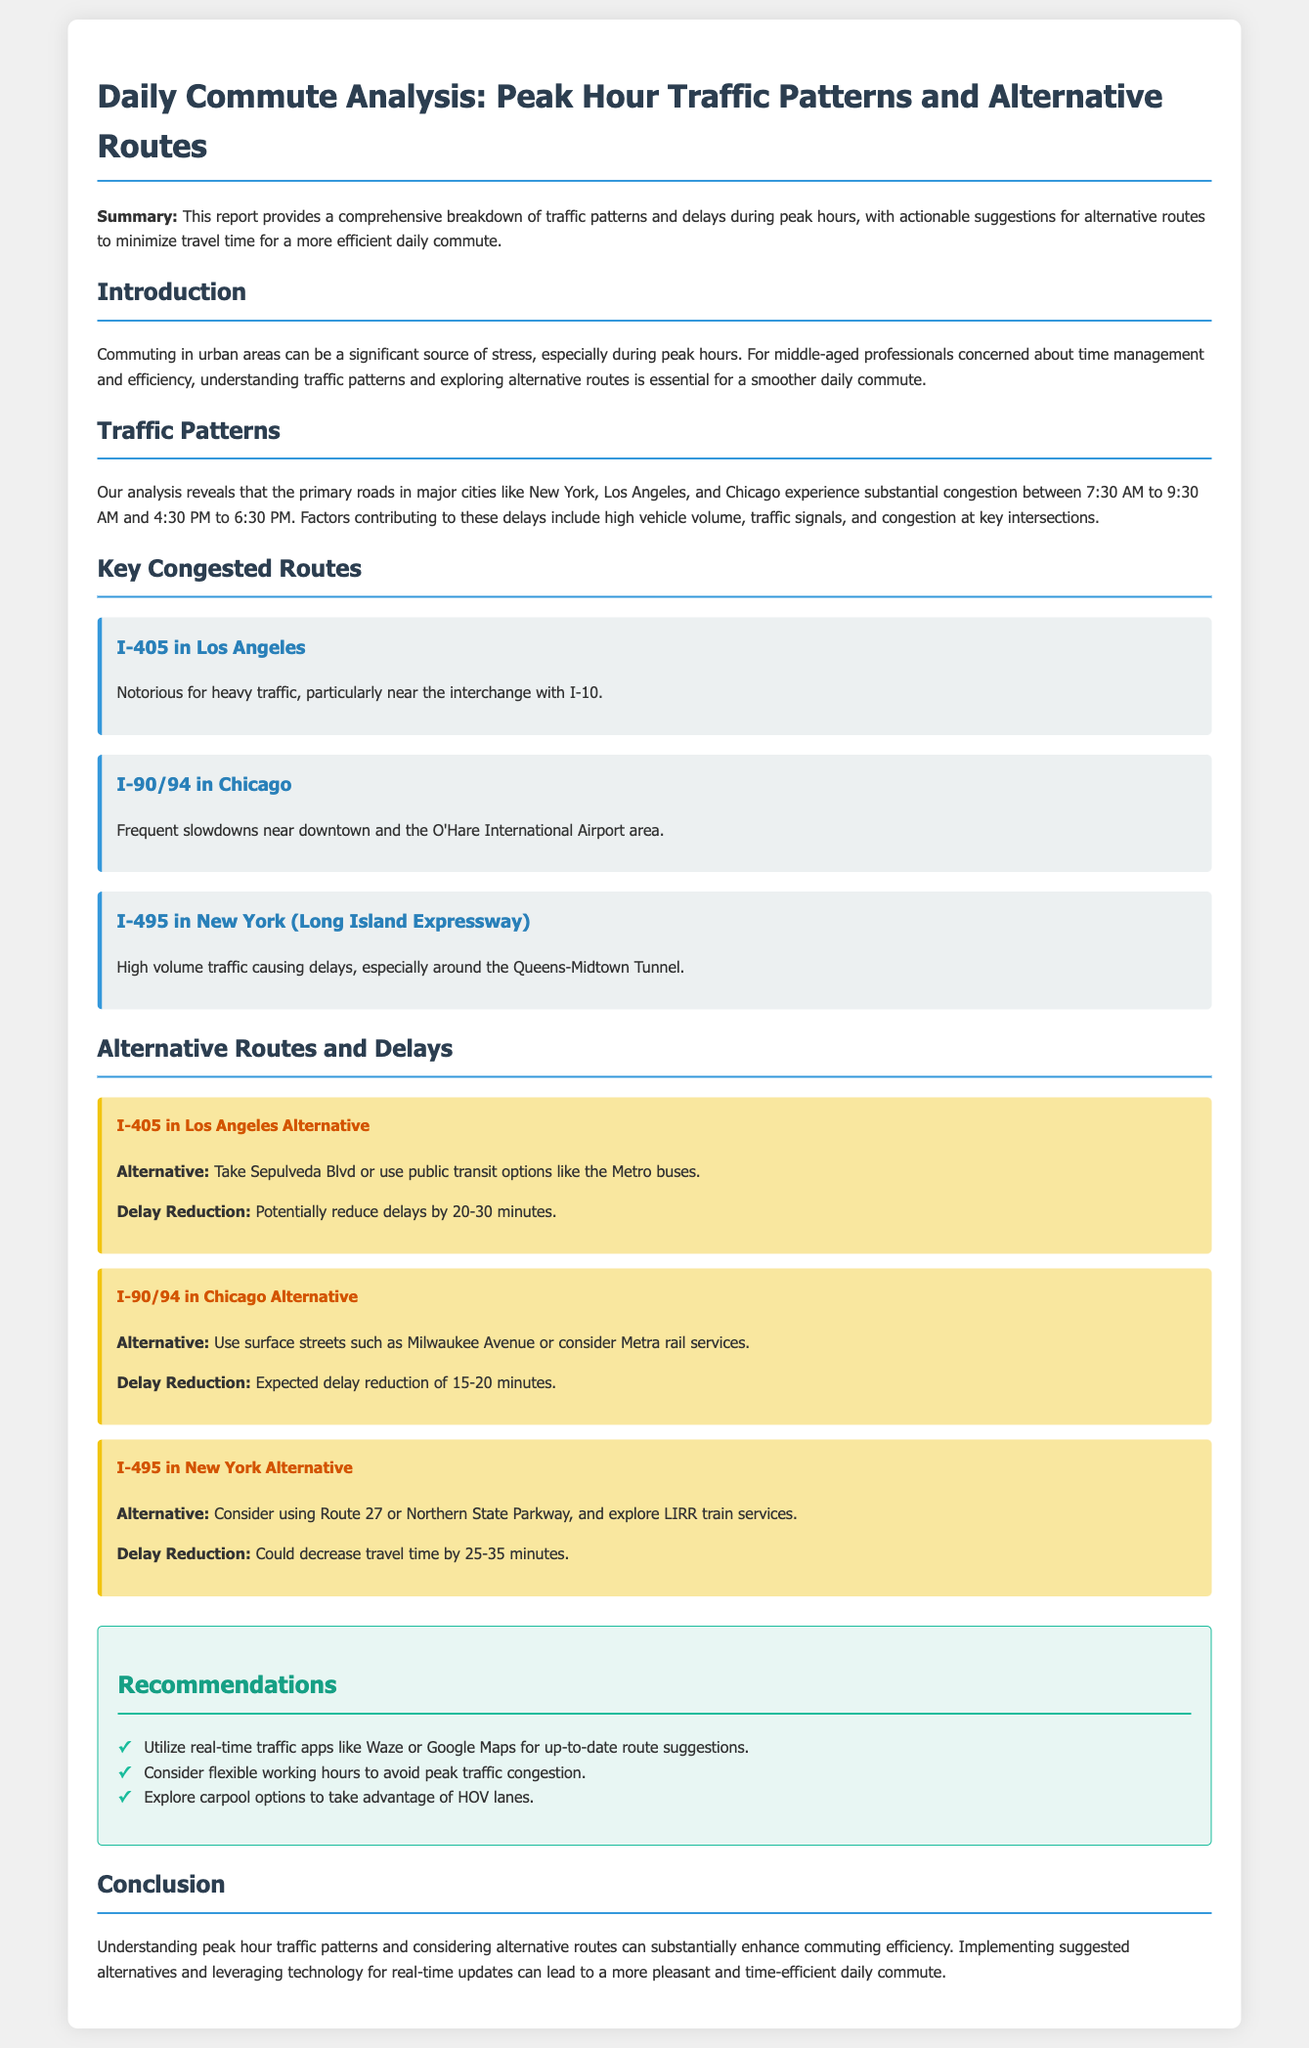What are the peak hours for traffic congestion? The document states that peak hours are from 7:30 AM to 9:30 AM and 4:30 PM to 6:30 PM.
Answer: 7:30 AM to 9:30 AM and 4:30 PM to 6:30 PM Which major city has congestion on I-405? I-405 is mentioned in the context of heavy traffic in Los Angeles.
Answer: Los Angeles What is one alternative route suggested for I-90/94 in Chicago? The alternative route suggested is using surface streets such as Milwaukee Avenue.
Answer: Surface streets such as Milwaukee Avenue How much can delays be reduced on I-405 in Los Angeles with the alternative route? The reported delay reduction is potentially 20-30 minutes.
Answer: 20-30 minutes What is a recommended tool for real-time traffic updates? The document recommends using real-time traffic apps like Waze or Google Maps.
Answer: Waze or Google Maps How many key congested routes are mentioned in the report? There are three key congested routes listed in the report.
Answer: Three What is a recommended action to avoid peak traffic congestion? The report recommends considering flexible working hours.
Answer: Flexible working hours Which highway is noted for heavy traffic near downtown Chicago? The document specifies I-90/94 as experiencing frequent slowdowns near downtown.
Answer: I-90/94 